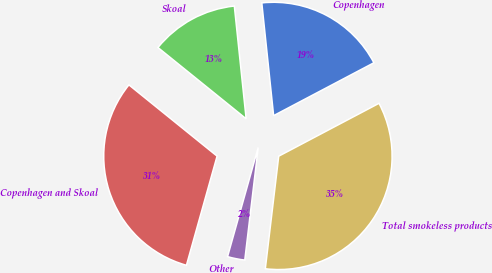Convert chart to OTSL. <chart><loc_0><loc_0><loc_500><loc_500><pie_chart><fcel>Copenhagen<fcel>Skoal<fcel>Copenhagen and Skoal<fcel>Other<fcel>Total smokeless products<nl><fcel>18.94%<fcel>12.52%<fcel>31.46%<fcel>2.47%<fcel>34.61%<nl></chart> 